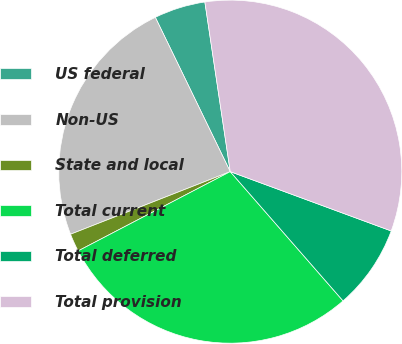Convert chart to OTSL. <chart><loc_0><loc_0><loc_500><loc_500><pie_chart><fcel>US federal<fcel>Non-US<fcel>State and local<fcel>Total current<fcel>Total deferred<fcel>Total provision<nl><fcel>4.83%<fcel>23.75%<fcel>1.7%<fcel>28.77%<fcel>7.96%<fcel>32.98%<nl></chart> 